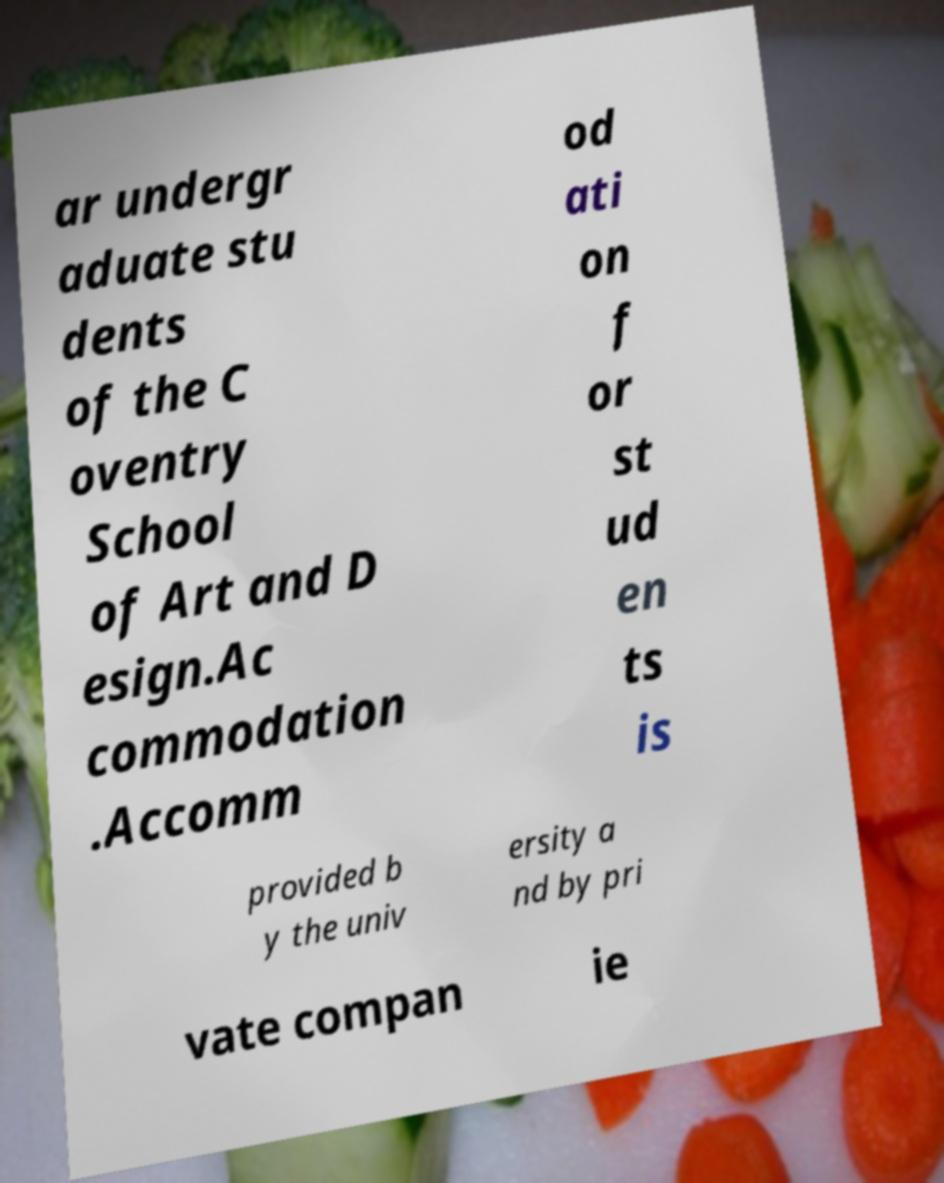Could you assist in decoding the text presented in this image and type it out clearly? ar undergr aduate stu dents of the C oventry School of Art and D esign.Ac commodation .Accomm od ati on f or st ud en ts is provided b y the univ ersity a nd by pri vate compan ie 